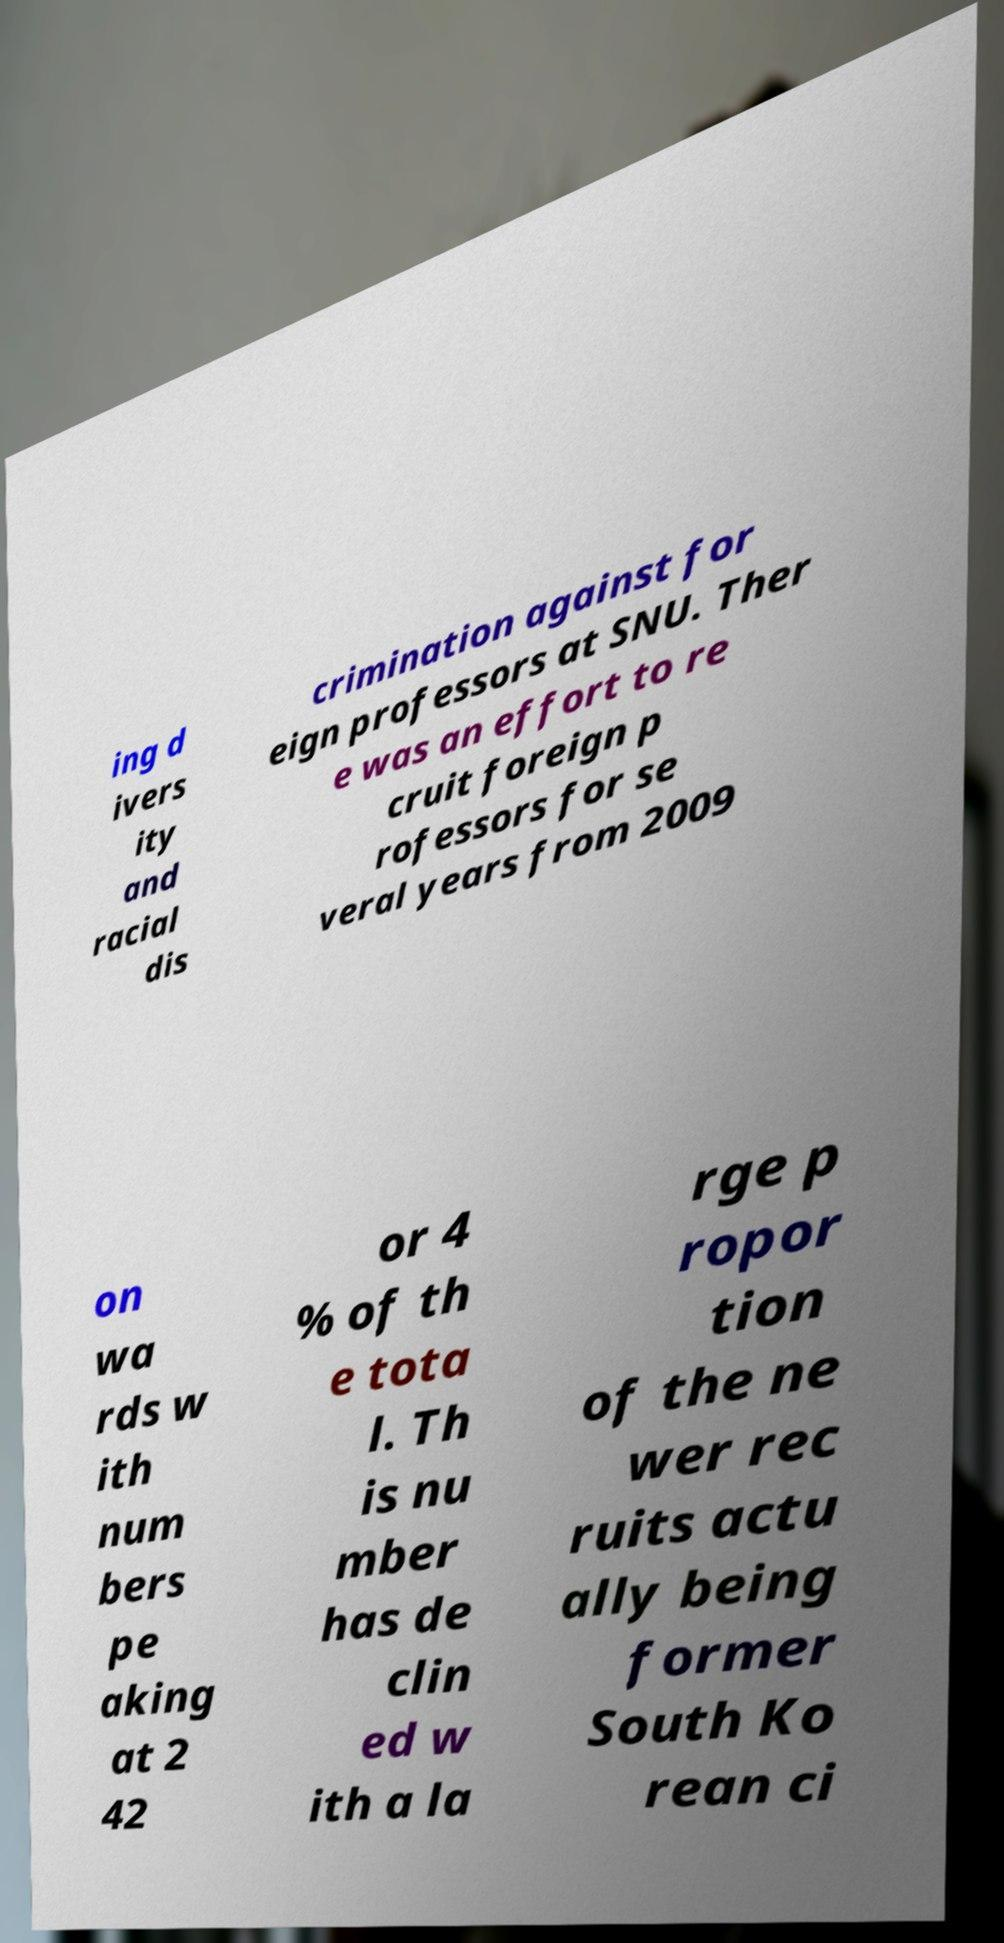Could you extract and type out the text from this image? ing d ivers ity and racial dis crimination against for eign professors at SNU. Ther e was an effort to re cruit foreign p rofessors for se veral years from 2009 on wa rds w ith num bers pe aking at 2 42 or 4 % of th e tota l. Th is nu mber has de clin ed w ith a la rge p ropor tion of the ne wer rec ruits actu ally being former South Ko rean ci 